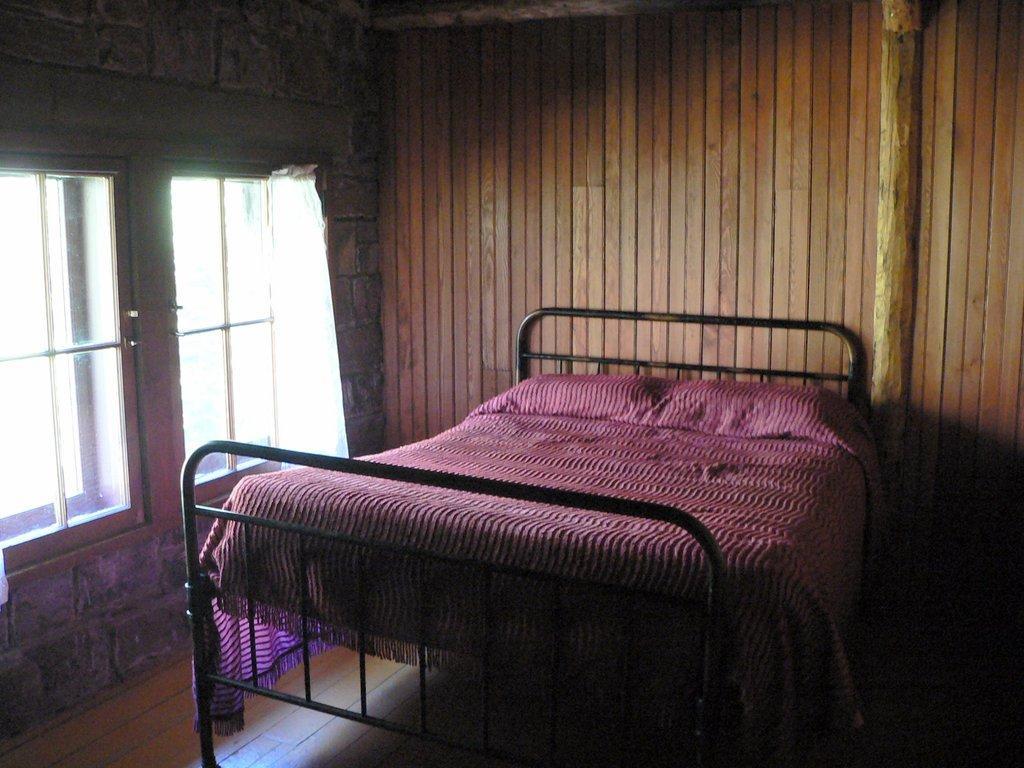Could you give a brief overview of what you see in this image? In this picture I see the inside view of a room and I see the bed in front of this image and on the left side of this image I see the windows and in the background I see the wall. 